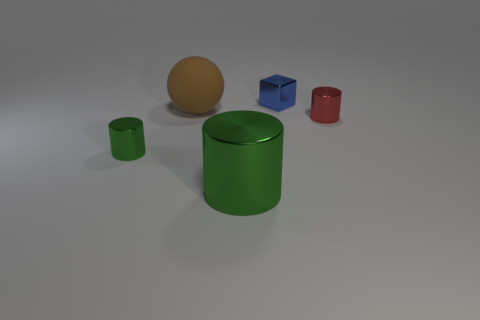What number of things are big brown things or large purple rubber blocks? There is only one large brown thing in the image, which is a sphere, and there are no large purple blocks present at all, resulting in a total count of one. 